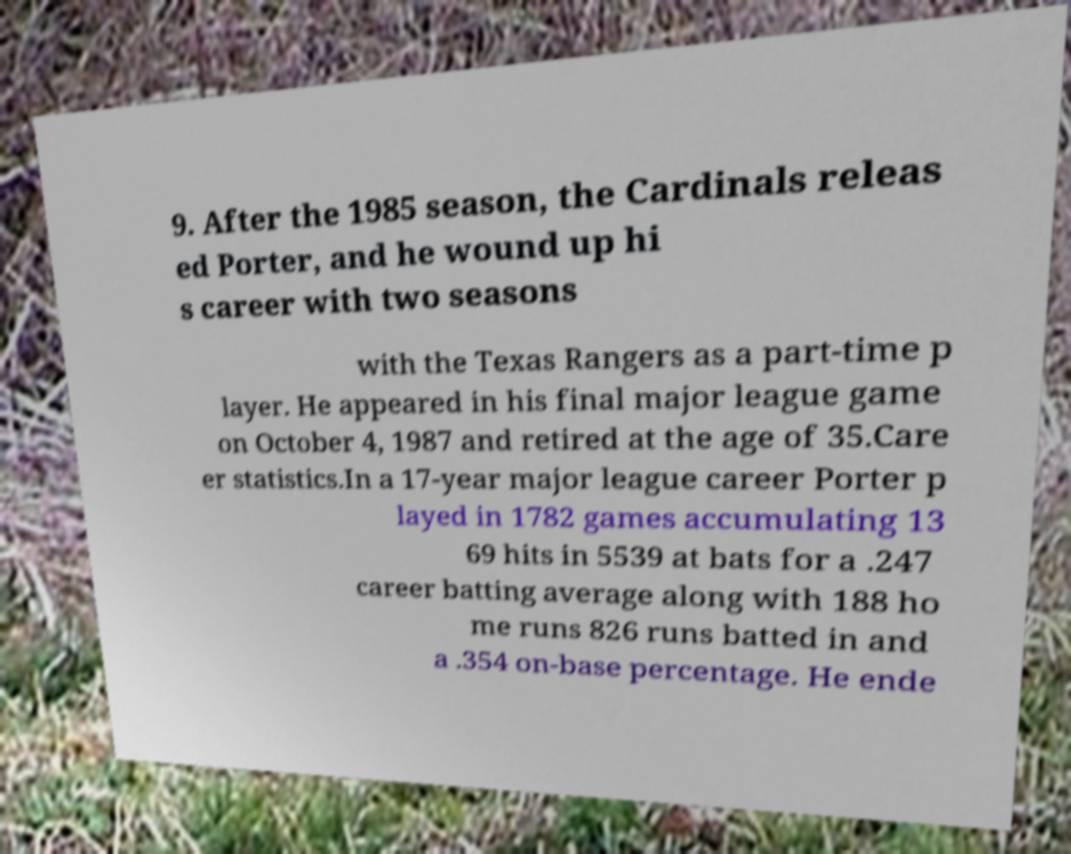I need the written content from this picture converted into text. Can you do that? 9. After the 1985 season, the Cardinals releas ed Porter, and he wound up hi s career with two seasons with the Texas Rangers as a part-time p layer. He appeared in his final major league game on October 4, 1987 and retired at the age of 35.Care er statistics.In a 17-year major league career Porter p layed in 1782 games accumulating 13 69 hits in 5539 at bats for a .247 career batting average along with 188 ho me runs 826 runs batted in and a .354 on-base percentage. He ende 